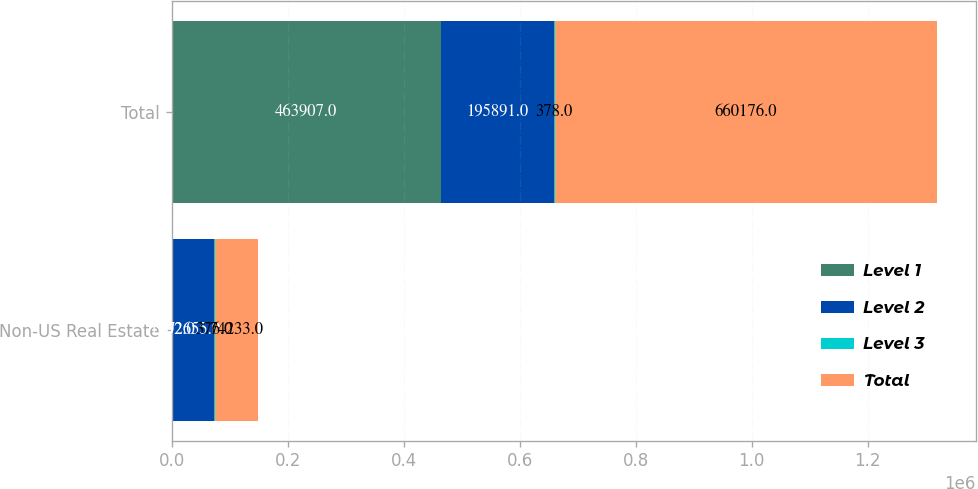Convert chart. <chart><loc_0><loc_0><loc_500><loc_500><stacked_bar_chart><ecel><fcel>Non-US Real Estate<fcel>Total<nl><fcel>Level 1<fcel>1202<fcel>463907<nl><fcel>Level 2<fcel>72655<fcel>195891<nl><fcel>Level 3<fcel>376<fcel>378<nl><fcel>Total<fcel>74233<fcel>660176<nl></chart> 